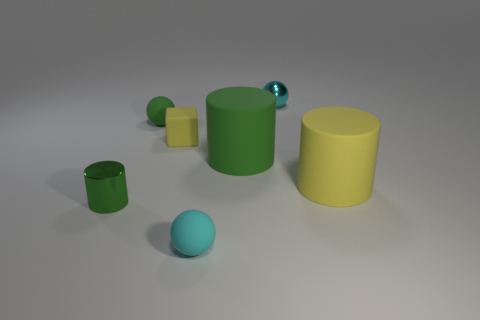Add 1 small green cylinders. How many objects exist? 8 Subtract all small shiny cylinders. How many cylinders are left? 2 Subtract all cyan balls. How many balls are left? 1 Subtract 1 blocks. How many blocks are left? 0 Subtract all spheres. How many objects are left? 4 Add 6 cylinders. How many cylinders exist? 9 Subtract 0 brown cubes. How many objects are left? 7 Subtract all red cubes. Subtract all purple cylinders. How many cubes are left? 1 Subtract all blue blocks. How many green cylinders are left? 2 Subtract all small rubber things. Subtract all big cylinders. How many objects are left? 2 